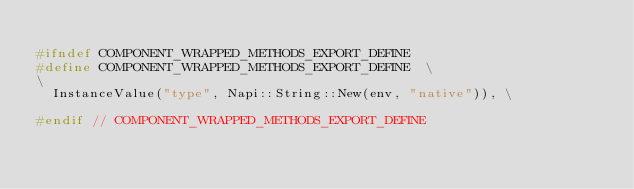<code> <loc_0><loc_0><loc_500><loc_500><_C_>
#ifndef COMPONENT_WRAPPED_METHODS_EXPORT_DEFINE
#define COMPONENT_WRAPPED_METHODS_EXPORT_DEFINE  \
\
  InstanceValue("type", Napi::String::New(env, "native")), \

#endif // COMPONENT_WRAPPED_METHODS_EXPORT_DEFINE
</code> 